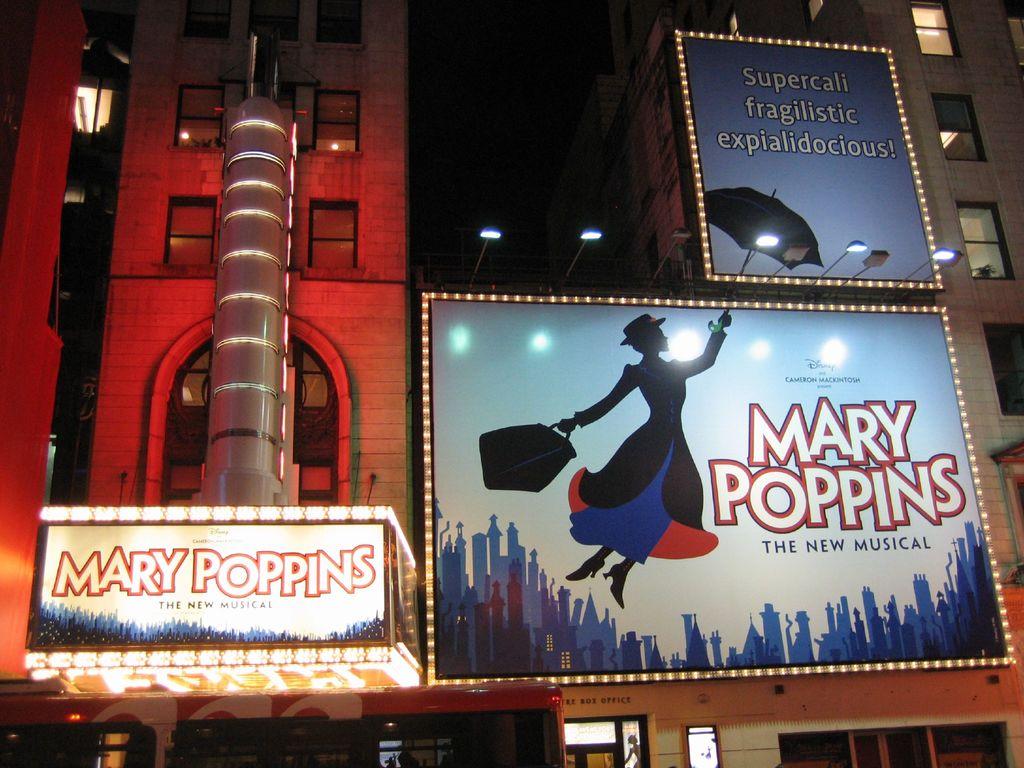What musical is being performed here?
Offer a terse response. Mary poppins. What film company sponsors this musical?
Ensure brevity in your answer.  Disney. 